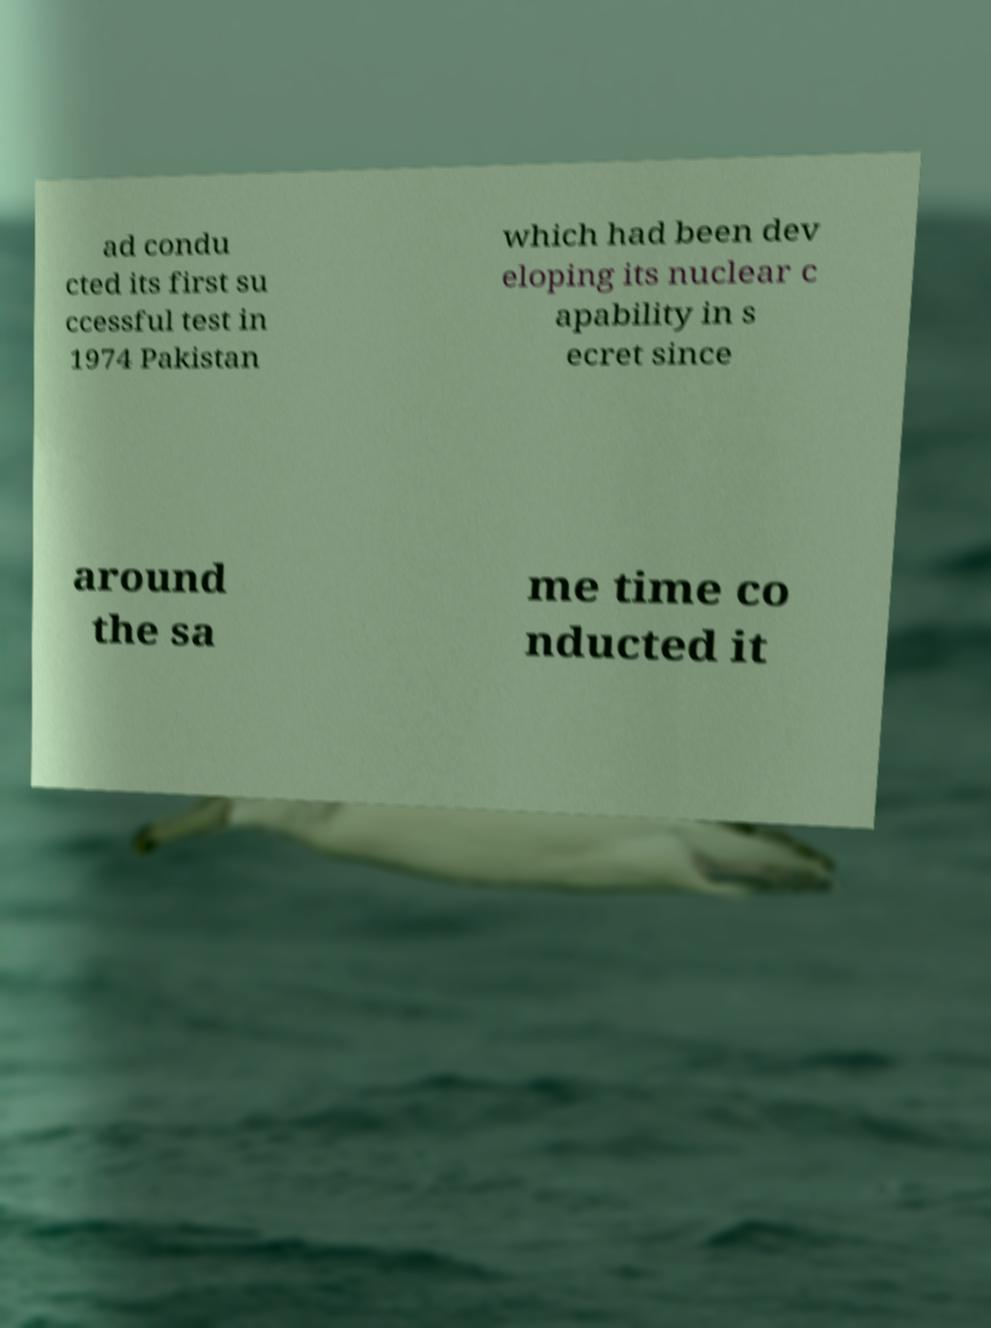Please identify and transcribe the text found in this image. ad condu cted its first su ccessful test in 1974 Pakistan which had been dev eloping its nuclear c apability in s ecret since around the sa me time co nducted it 